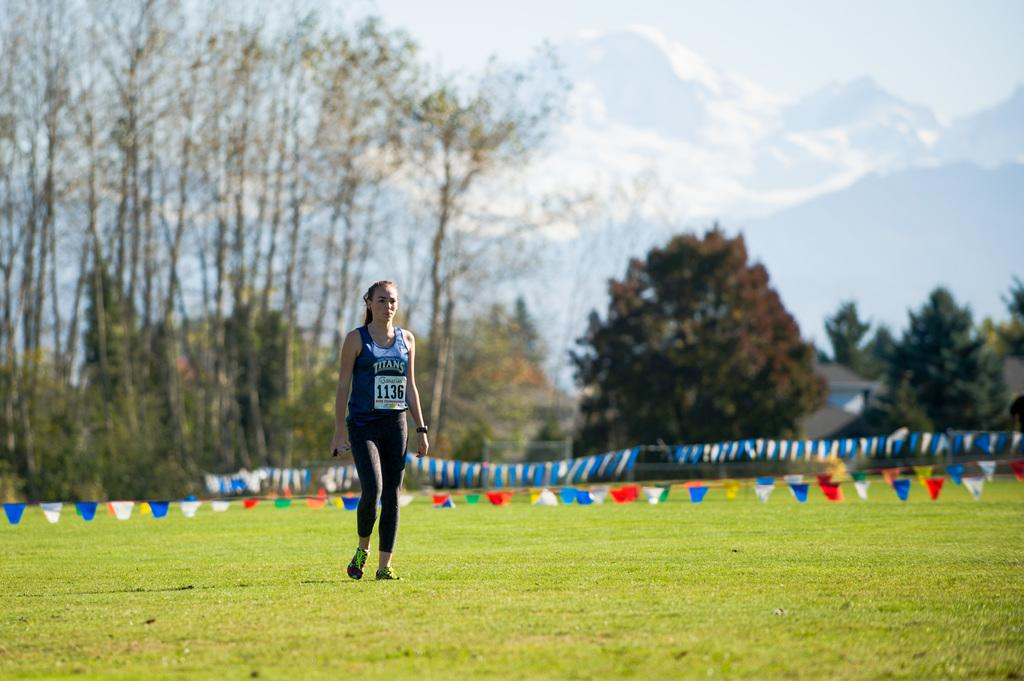Provide a one-sentence caption for the provided image. A woman in a Titans tank top walks across a field. 